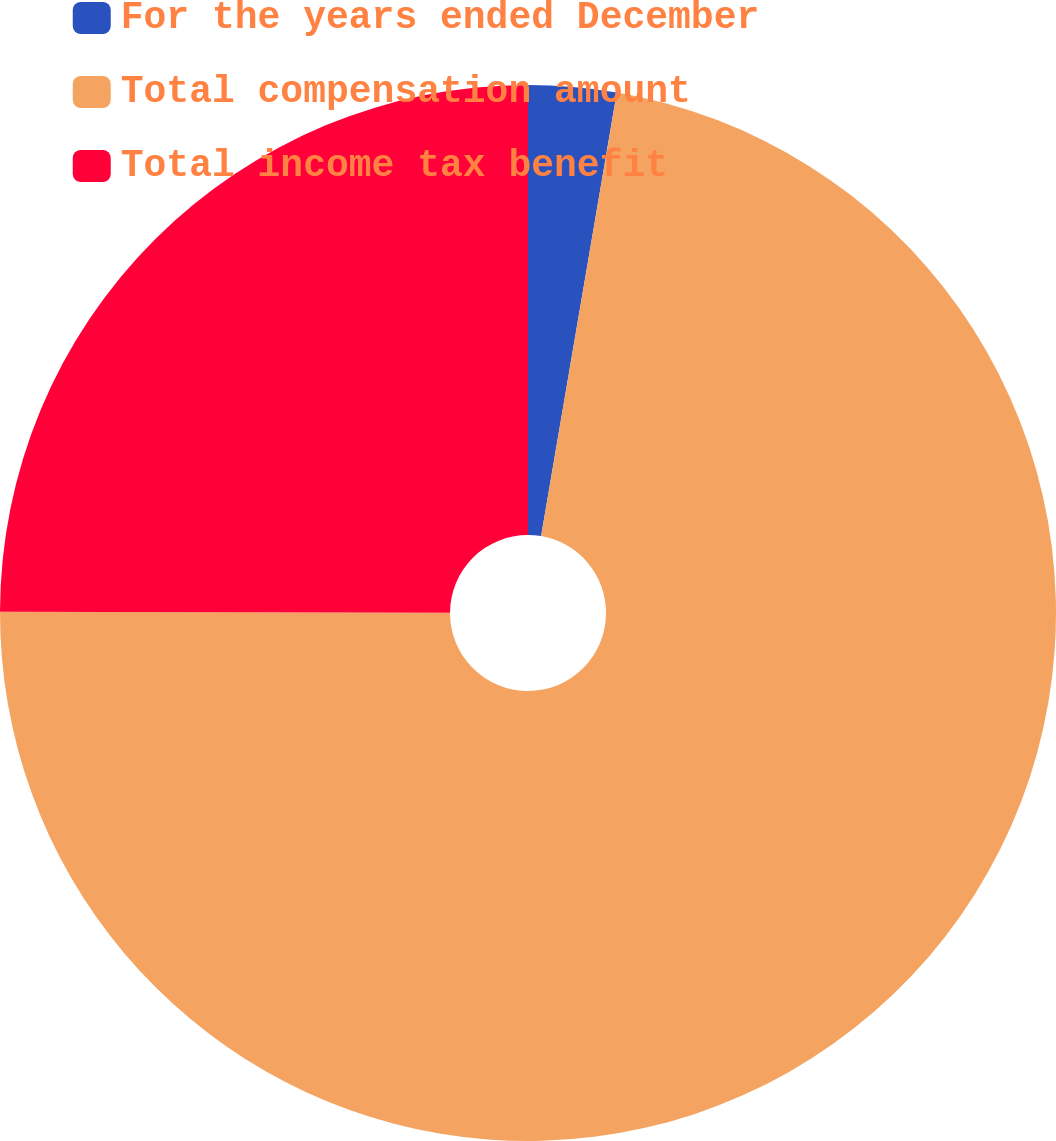Convert chart. <chart><loc_0><loc_0><loc_500><loc_500><pie_chart><fcel>For the years ended December<fcel>Total compensation amount<fcel>Total income tax benefit<nl><fcel>2.69%<fcel>72.35%<fcel>24.96%<nl></chart> 